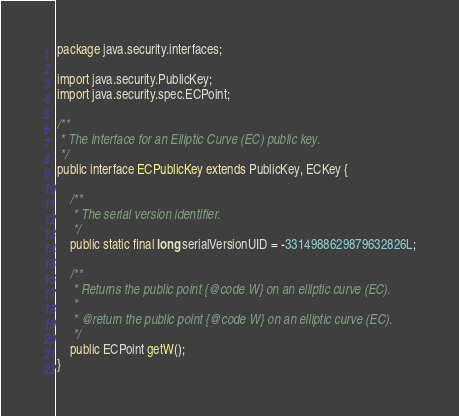Convert code to text. <code><loc_0><loc_0><loc_500><loc_500><_Java_>
package java.security.interfaces;

import java.security.PublicKey;
import java.security.spec.ECPoint;

/**
 * The interface for an Elliptic Curve (EC) public key.
 */
public interface ECPublicKey extends PublicKey, ECKey {

	/**
	 * The serial version identifier.
	 */
	public static final long serialVersionUID = -3314988629879632826L;

	/**
	 * Returns the public point {@code W} on an elliptic curve (EC).
	 * 
	 * @return the public point {@code W} on an elliptic curve (EC).
	 */
	public ECPoint getW();
}
</code> 